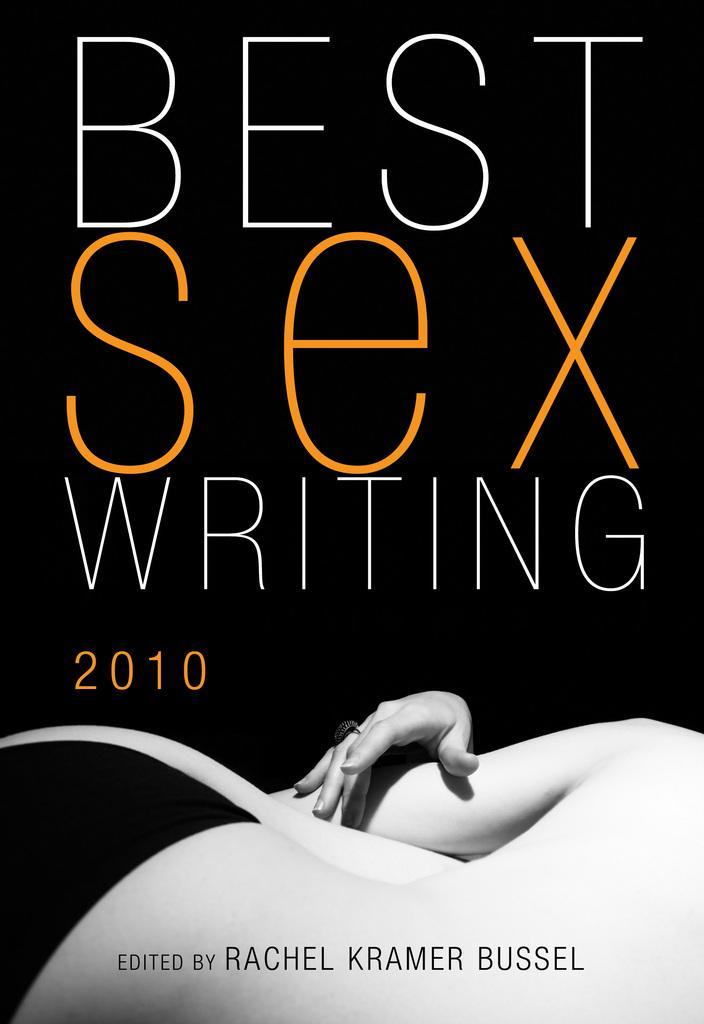Can you describe this image briefly? In the picture we can see a book with a name on it as "Best sex writing 2010". 